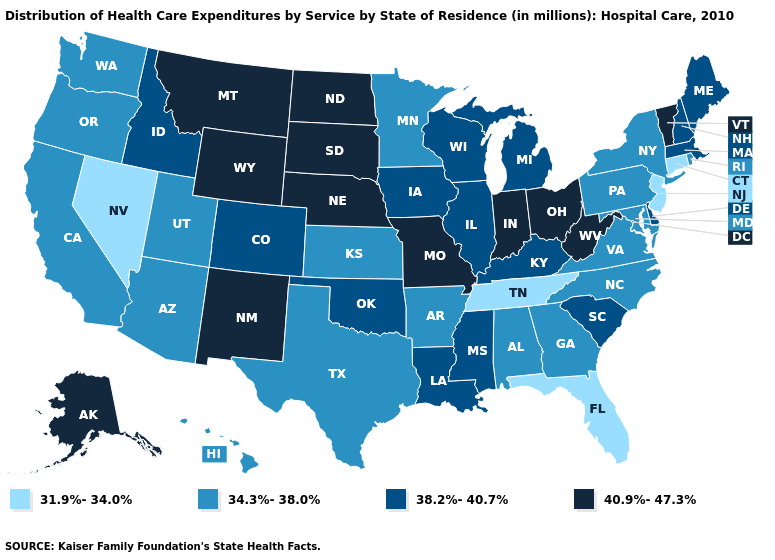Among the states that border Indiana , which have the highest value?
Give a very brief answer. Ohio. What is the value of Utah?
Short answer required. 34.3%-38.0%. Does Delaware have a lower value than Ohio?
Keep it brief. Yes. What is the value of Wyoming?
Concise answer only. 40.9%-47.3%. Name the states that have a value in the range 34.3%-38.0%?
Write a very short answer. Alabama, Arizona, Arkansas, California, Georgia, Hawaii, Kansas, Maryland, Minnesota, New York, North Carolina, Oregon, Pennsylvania, Rhode Island, Texas, Utah, Virginia, Washington. Does Arkansas have a higher value than Louisiana?
Keep it brief. No. Name the states that have a value in the range 40.9%-47.3%?
Short answer required. Alaska, Indiana, Missouri, Montana, Nebraska, New Mexico, North Dakota, Ohio, South Dakota, Vermont, West Virginia, Wyoming. What is the value of Maryland?
Quick response, please. 34.3%-38.0%. Name the states that have a value in the range 40.9%-47.3%?
Write a very short answer. Alaska, Indiana, Missouri, Montana, Nebraska, New Mexico, North Dakota, Ohio, South Dakota, Vermont, West Virginia, Wyoming. Name the states that have a value in the range 34.3%-38.0%?
Quick response, please. Alabama, Arizona, Arkansas, California, Georgia, Hawaii, Kansas, Maryland, Minnesota, New York, North Carolina, Oregon, Pennsylvania, Rhode Island, Texas, Utah, Virginia, Washington. What is the lowest value in the South?
Short answer required. 31.9%-34.0%. Name the states that have a value in the range 38.2%-40.7%?
Short answer required. Colorado, Delaware, Idaho, Illinois, Iowa, Kentucky, Louisiana, Maine, Massachusetts, Michigan, Mississippi, New Hampshire, Oklahoma, South Carolina, Wisconsin. What is the highest value in the Northeast ?
Write a very short answer. 40.9%-47.3%. Name the states that have a value in the range 38.2%-40.7%?
Write a very short answer. Colorado, Delaware, Idaho, Illinois, Iowa, Kentucky, Louisiana, Maine, Massachusetts, Michigan, Mississippi, New Hampshire, Oklahoma, South Carolina, Wisconsin. What is the value of North Carolina?
Be succinct. 34.3%-38.0%. 